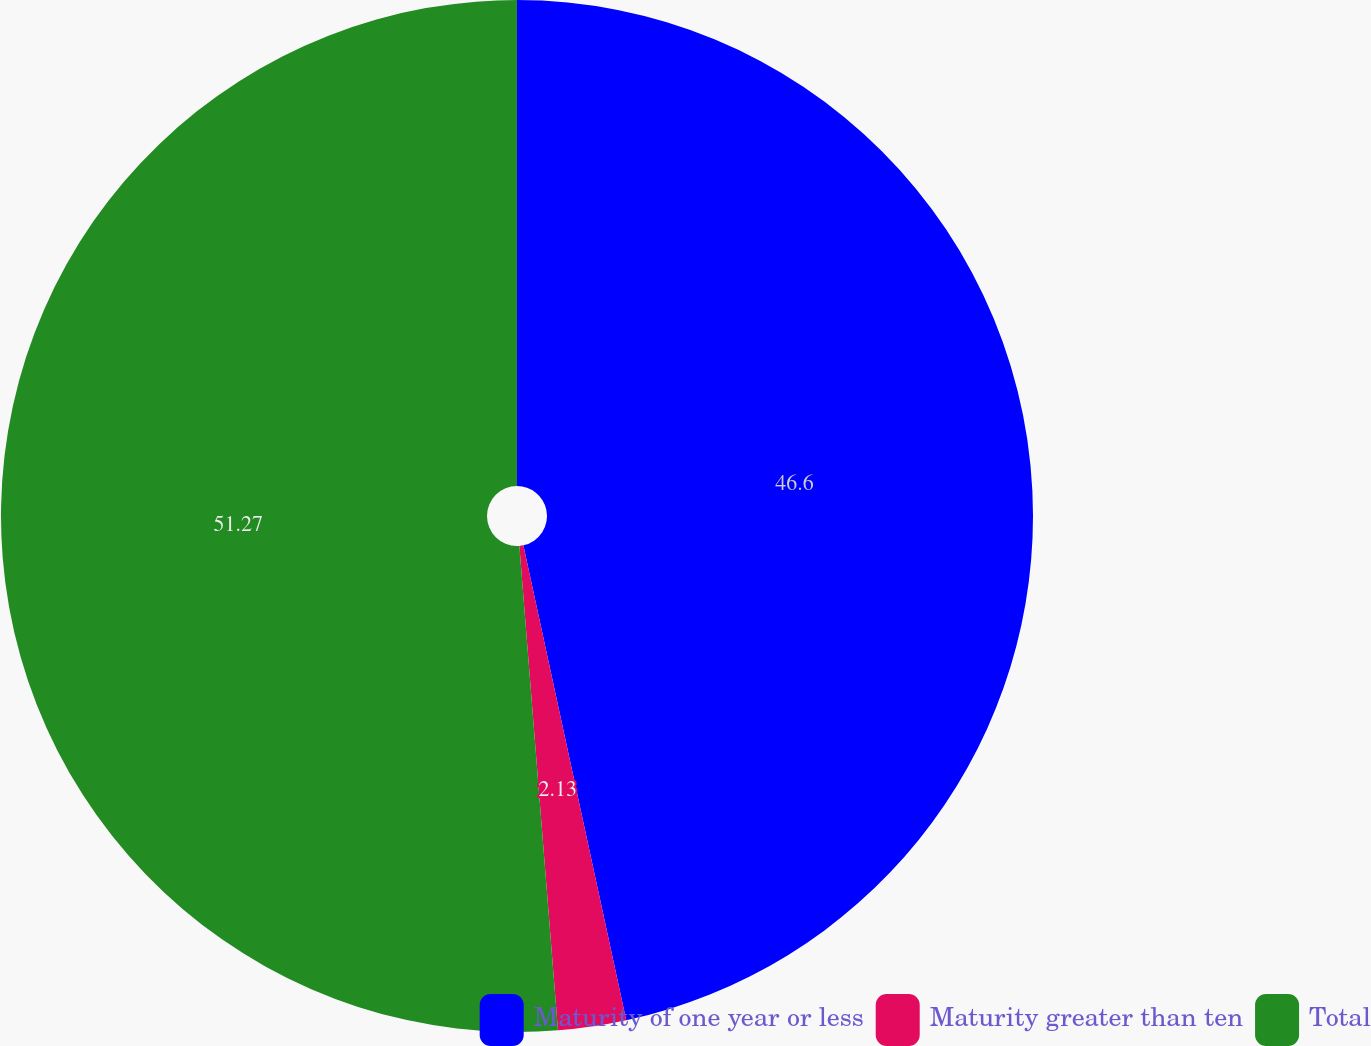<chart> <loc_0><loc_0><loc_500><loc_500><pie_chart><fcel>Maturity of one year or less<fcel>Maturity greater than ten<fcel>Total<nl><fcel>46.6%<fcel>2.13%<fcel>51.26%<nl></chart> 